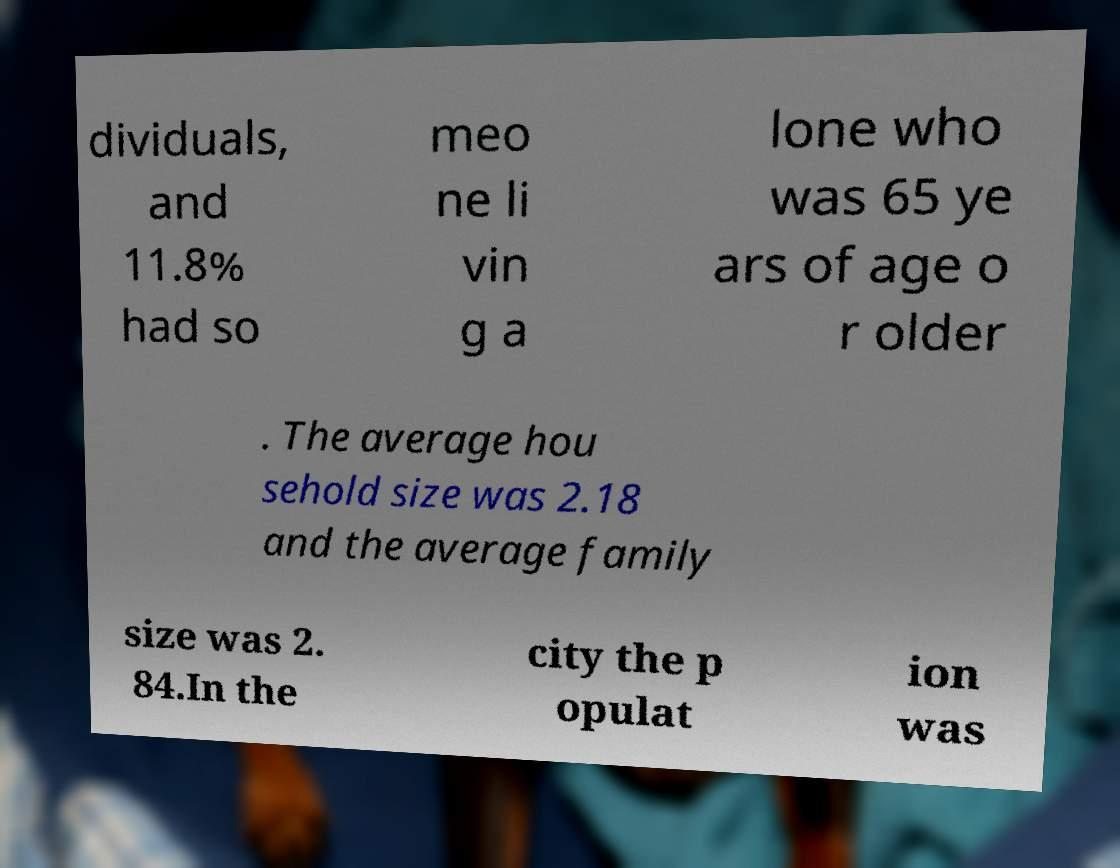I need the written content from this picture converted into text. Can you do that? dividuals, and 11.8% had so meo ne li vin g a lone who was 65 ye ars of age o r older . The average hou sehold size was 2.18 and the average family size was 2. 84.In the city the p opulat ion was 